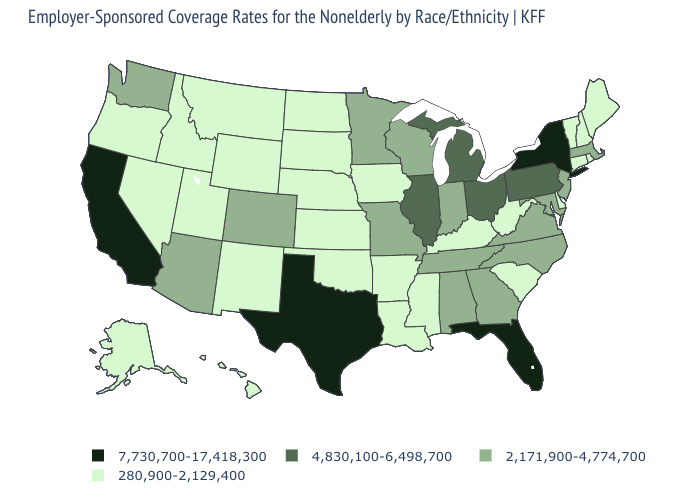Name the states that have a value in the range 7,730,700-17,418,300?
Concise answer only. California, Florida, New York, Texas. Name the states that have a value in the range 280,900-2,129,400?
Give a very brief answer. Alaska, Arkansas, Connecticut, Delaware, Hawaii, Idaho, Iowa, Kansas, Kentucky, Louisiana, Maine, Mississippi, Montana, Nebraska, Nevada, New Hampshire, New Mexico, North Dakota, Oklahoma, Oregon, Rhode Island, South Carolina, South Dakota, Utah, Vermont, West Virginia, Wyoming. How many symbols are there in the legend?
Quick response, please. 4. Which states have the highest value in the USA?
Answer briefly. California, Florida, New York, Texas. What is the value of Michigan?
Answer briefly. 4,830,100-6,498,700. What is the value of South Dakota?
Give a very brief answer. 280,900-2,129,400. Does Kansas have the highest value in the MidWest?
Concise answer only. No. Does Maine have a lower value than Montana?
Concise answer only. No. Does Delaware have a lower value than Ohio?
Write a very short answer. Yes. How many symbols are there in the legend?
Concise answer only. 4. What is the value of Texas?
Be succinct. 7,730,700-17,418,300. Name the states that have a value in the range 280,900-2,129,400?
Quick response, please. Alaska, Arkansas, Connecticut, Delaware, Hawaii, Idaho, Iowa, Kansas, Kentucky, Louisiana, Maine, Mississippi, Montana, Nebraska, Nevada, New Hampshire, New Mexico, North Dakota, Oklahoma, Oregon, Rhode Island, South Carolina, South Dakota, Utah, Vermont, West Virginia, Wyoming. Does Arizona have the highest value in the West?
Quick response, please. No. Does the first symbol in the legend represent the smallest category?
Write a very short answer. No. 